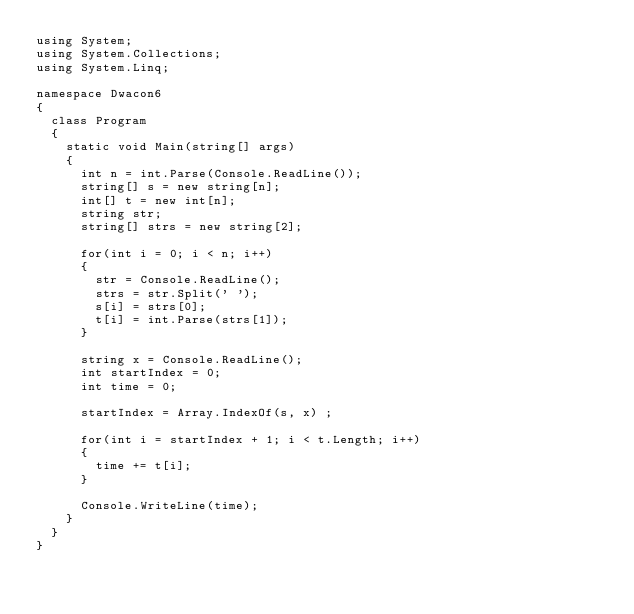Convert code to text. <code><loc_0><loc_0><loc_500><loc_500><_C#_>using System;
using System.Collections;
using System.Linq;

namespace Dwacon6
{
	class Program
	{
		static void Main(string[] args)
		{
			int n = int.Parse(Console.ReadLine());
			string[] s = new string[n];
			int[] t = new int[n];
			string str;
			string[] strs = new string[2];

			for(int i = 0; i < n; i++)
			{
				str = Console.ReadLine();
				strs = str.Split(' ');
				s[i] = strs[0];
				t[i] = int.Parse(strs[1]);
			}

			string x = Console.ReadLine();
			int startIndex = 0;
			int time = 0;

			startIndex = Array.IndexOf(s, x) ;

			for(int i = startIndex + 1; i < t.Length; i++)
			{
				time += t[i];
			}

			Console.WriteLine(time);
		}
	}
}</code> 